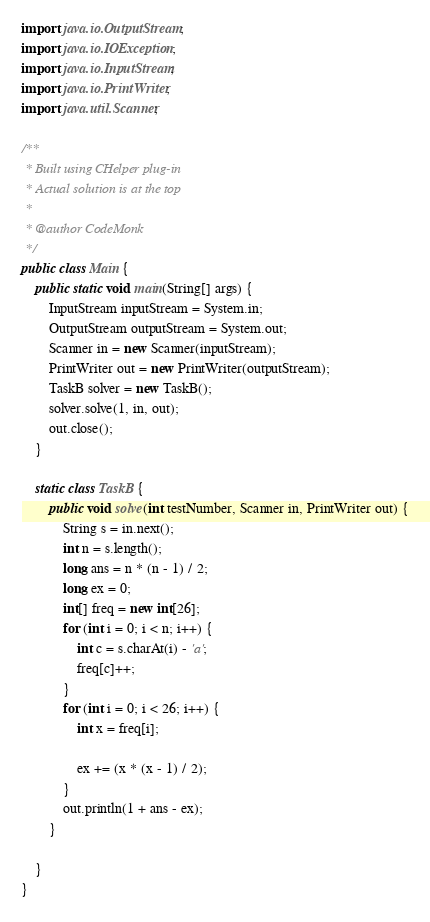Convert code to text. <code><loc_0><loc_0><loc_500><loc_500><_Java_>import java.io.OutputStream;
import java.io.IOException;
import java.io.InputStream;
import java.io.PrintWriter;
import java.util.Scanner;

/**
 * Built using CHelper plug-in
 * Actual solution is at the top
 *
 * @author CodeMonk
 */
public class Main {
    public static void main(String[] args) {
        InputStream inputStream = System.in;
        OutputStream outputStream = System.out;
        Scanner in = new Scanner(inputStream);
        PrintWriter out = new PrintWriter(outputStream);
        TaskB solver = new TaskB();
        solver.solve(1, in, out);
        out.close();
    }

    static class TaskB {
        public void solve(int testNumber, Scanner in, PrintWriter out) {
            String s = in.next();
            int n = s.length();
            long ans = n * (n - 1) / 2;
            long ex = 0;
            int[] freq = new int[26];
            for (int i = 0; i < n; i++) {
                int c = s.charAt(i) - 'a';
                freq[c]++;
            }
            for (int i = 0; i < 26; i++) {
                int x = freq[i];

                ex += (x * (x - 1) / 2);
            }
            out.println(1 + ans - ex);
        }

    }
}

</code> 